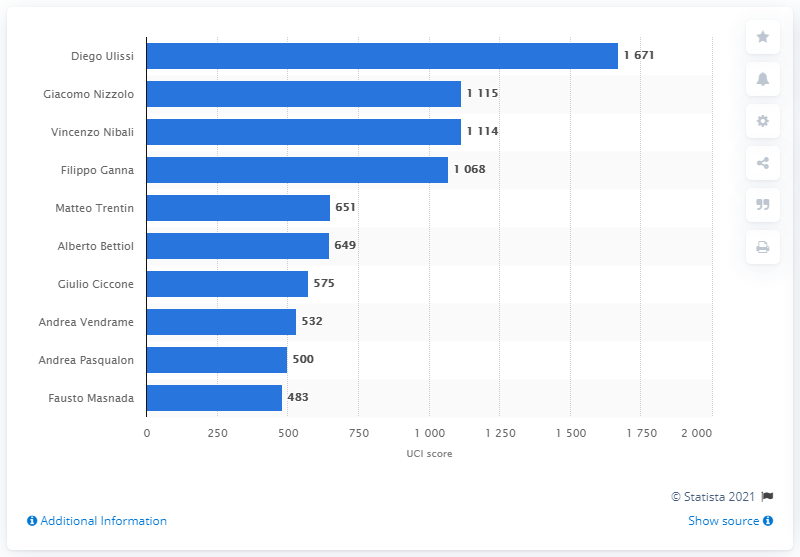Specify some key components in this picture. Giacomo Nizzolo ranked 26th worldwide in the UCI World Ranking. 